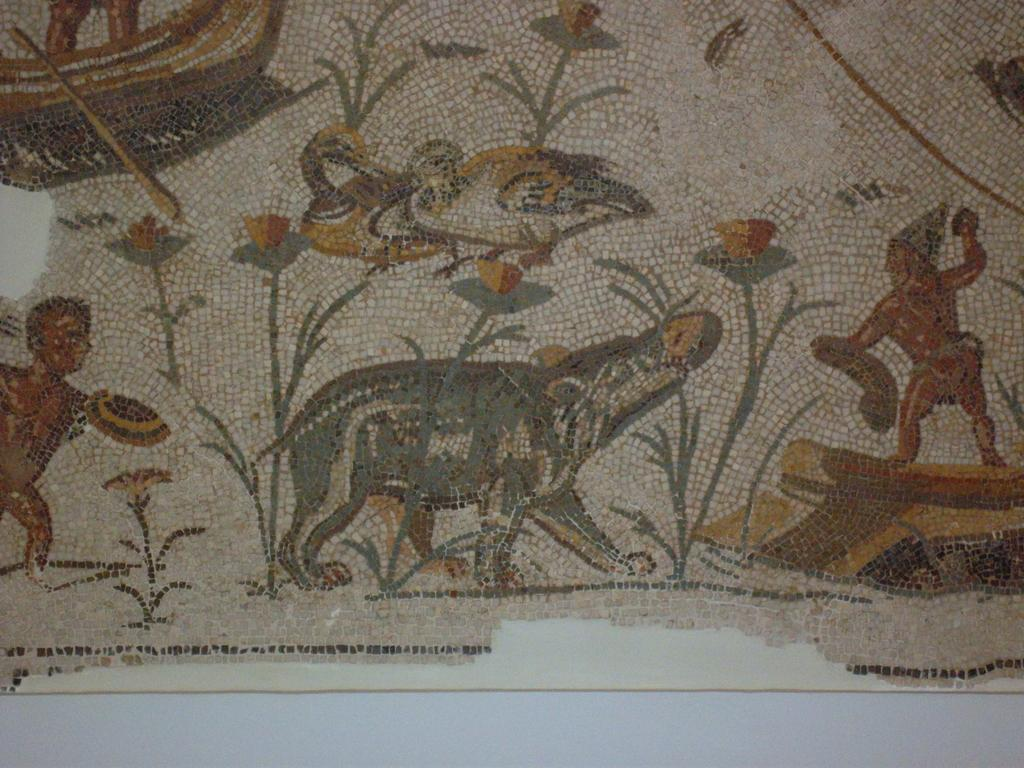What is depicted on the poster in the image? The poster features an art of humans and animals. Where is the poster located in the image? The poster is on a wall. How many men are lifting the poster in the image? There are no men present in the image, nor is anyone lifting the poster. 